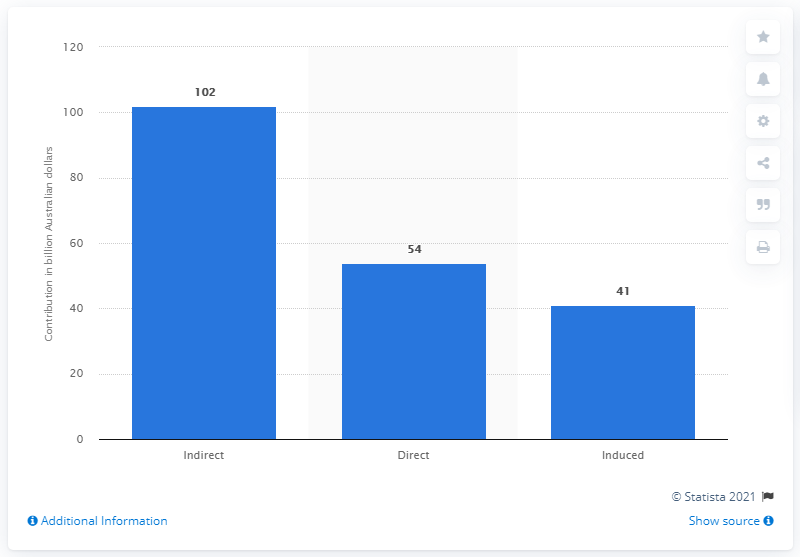Outline some significant characteristics in this image. In 2017, the indirect contribution of the travel and tourism industry to the gross domestic product of Australia was valued at AUD 102 billion. 